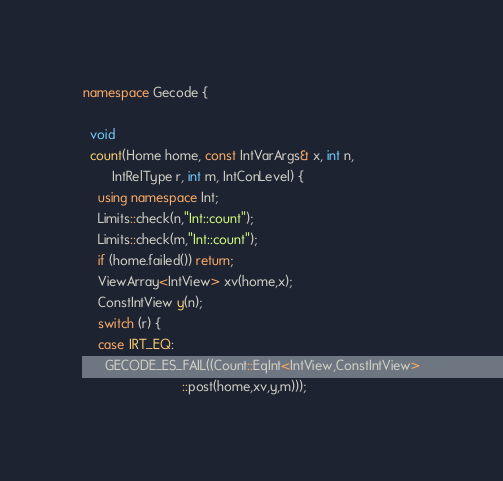Convert code to text. <code><loc_0><loc_0><loc_500><loc_500><_C++_>namespace Gecode {

  void
  count(Home home, const IntVarArgs& x, int n,
        IntRelType r, int m, IntConLevel) {
    using namespace Int;
    Limits::check(n,"Int::count");
    Limits::check(m,"Int::count");
    if (home.failed()) return;
    ViewArray<IntView> xv(home,x);
    ConstIntView y(n);
    switch (r) {
    case IRT_EQ:
      GECODE_ES_FAIL((Count::EqInt<IntView,ConstIntView>
                           ::post(home,xv,y,m)));</code> 